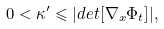Convert formula to latex. <formula><loc_0><loc_0><loc_500><loc_500>0 < \kappa ^ { \prime } \leqslant | d e t [ \nabla _ { x } \Phi _ { t } ] | ,</formula> 